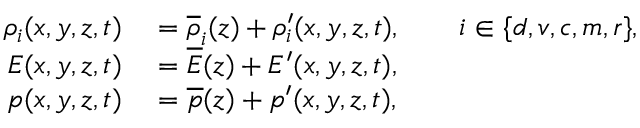<formula> <loc_0><loc_0><loc_500><loc_500>\begin{array} { r l } { \rho _ { i } ( x , y , z , t ) } & = \overline { \rho } _ { i } ( z ) + \rho _ { i } ^ { \prime } ( x , y , z , t ) , \quad i \in \{ d , v , c , m , r \} , } \\ { E ( x , y , z , t ) } & = \overline { E } ( z ) + { E } ^ { \prime } ( x , y , z , t ) , } \\ { p ( x , y , z , t ) } & = \overline { p } ( z ) + p ^ { \prime } ( x , y , z , t ) , } \end{array}</formula> 